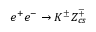Convert formula to latex. <formula><loc_0><loc_0><loc_500><loc_500>e ^ { + } e ^ { - } \to K ^ { \pm } Z _ { c s } ^ { \mp }</formula> 